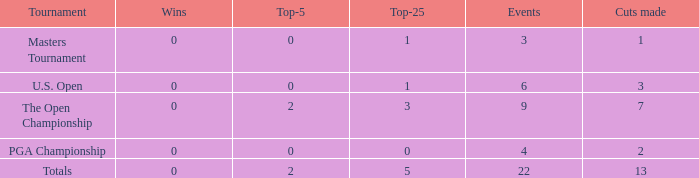What is the total number of wins for events with under 2 top-5s, under 5 top-25s, and more than 4 events played? 1.0. 